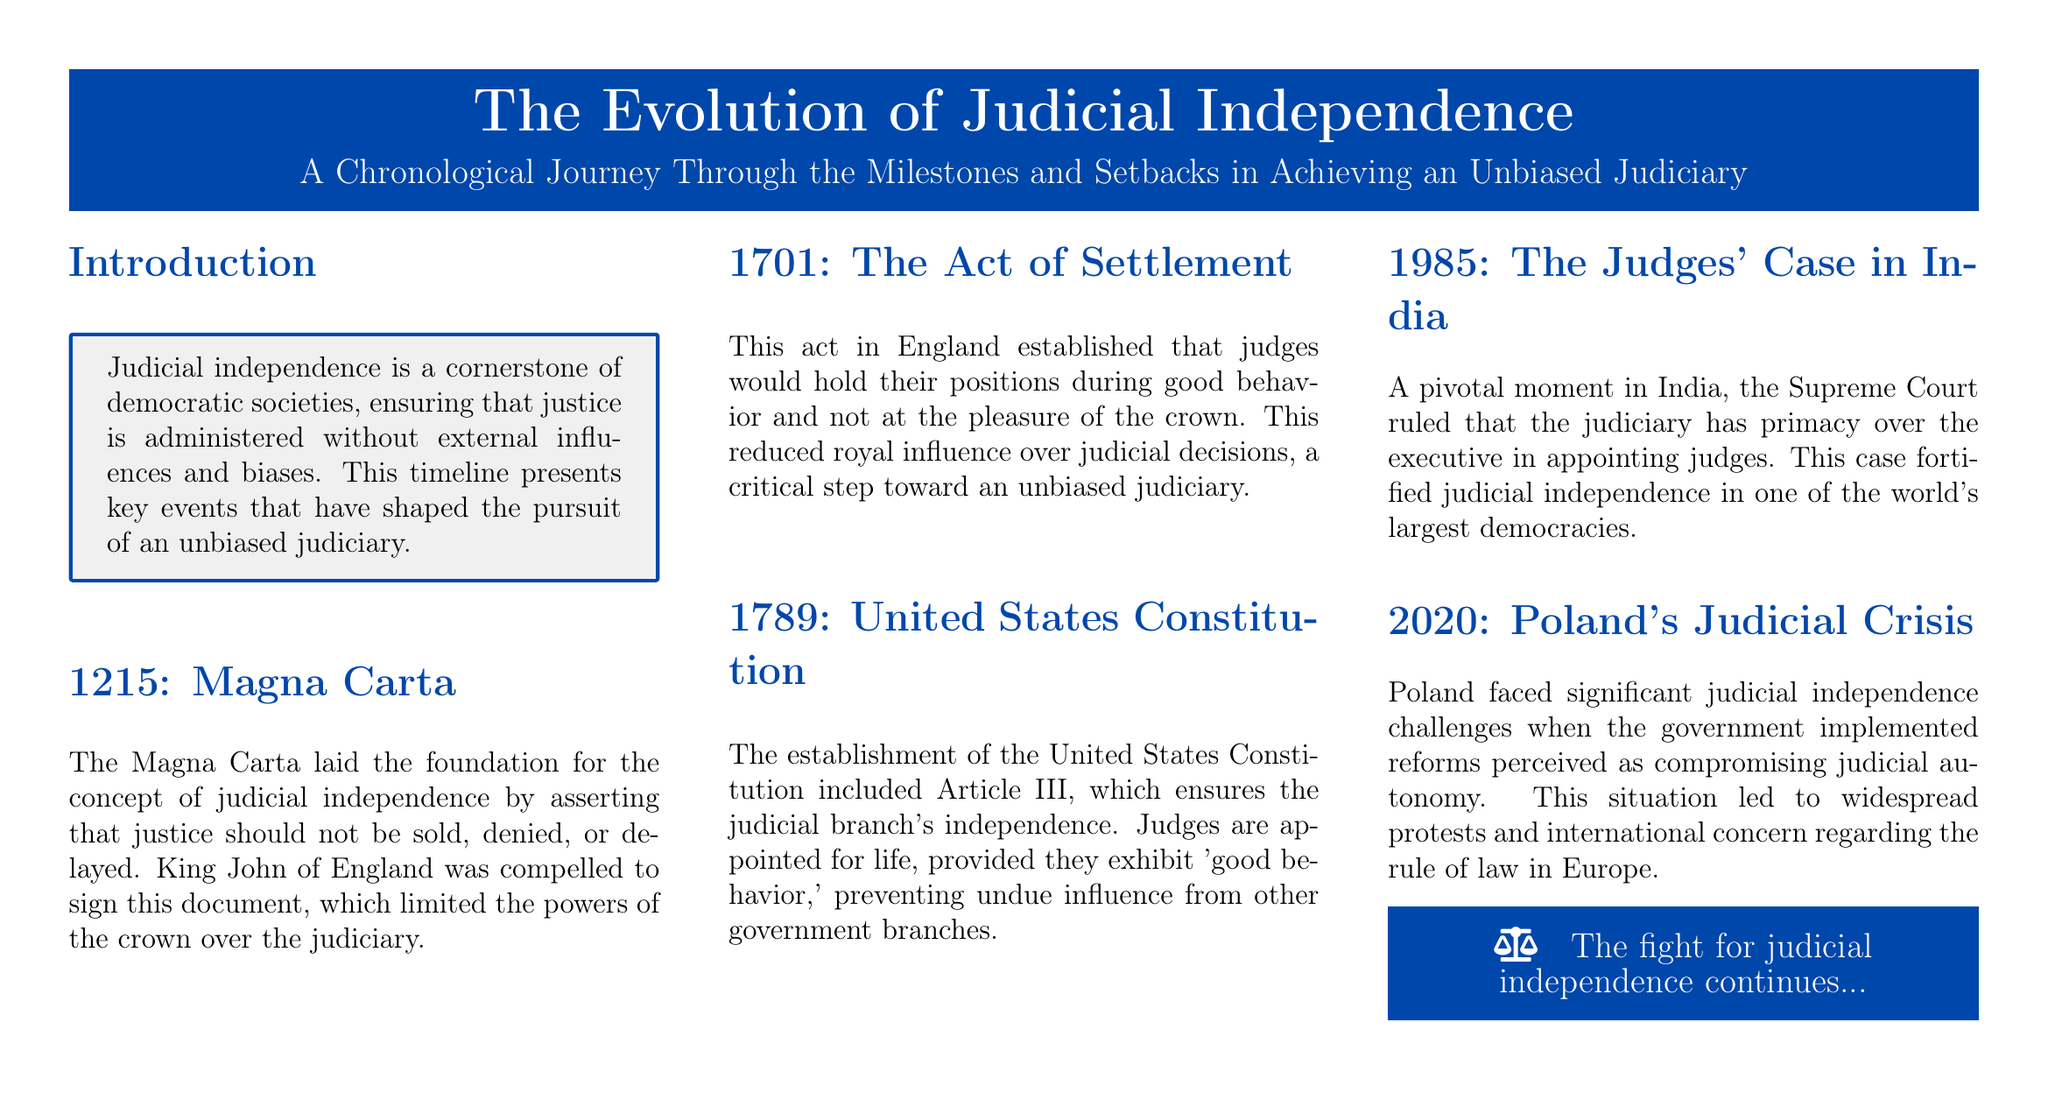What is the title of the document? The title of the document is presented at the top of the layout in a large font.
Answer: The Evolution of Judicial Independence What year was the Magna Carta signed? The document mentions that the Magna Carta was signed in 1215.
Answer: 1215 What significant act was established in England in 1701? The document refers to the establishment of the Act of Settlement in England in 1701.
Answer: The Act of Settlement Which article of the U.S. Constitution addresses judicial independence? The document states that Article III of the United States Constitution addresses judicial independence.
Answer: Article III What year did the Judges' Case occur in India? The document mentions that the Judges' Case occurred in India in 1985.
Answer: 1985 What event is described in Poland in 2020? The document discusses a judicial crisis in Poland that took place in 2020.
Answer: Judicial crisis What is the primary theme of this timeline? The document introduces the idea that the timeline covers key events related to judicial independence.
Answer: Judicial independence What format is used for the sections in the document? The document uses a chronological format to present the milestones and setbacks.
Answer: Chronological format What type of document is this? The structure and style indicate that this is a magazine layout.
Answer: Magazine layout 